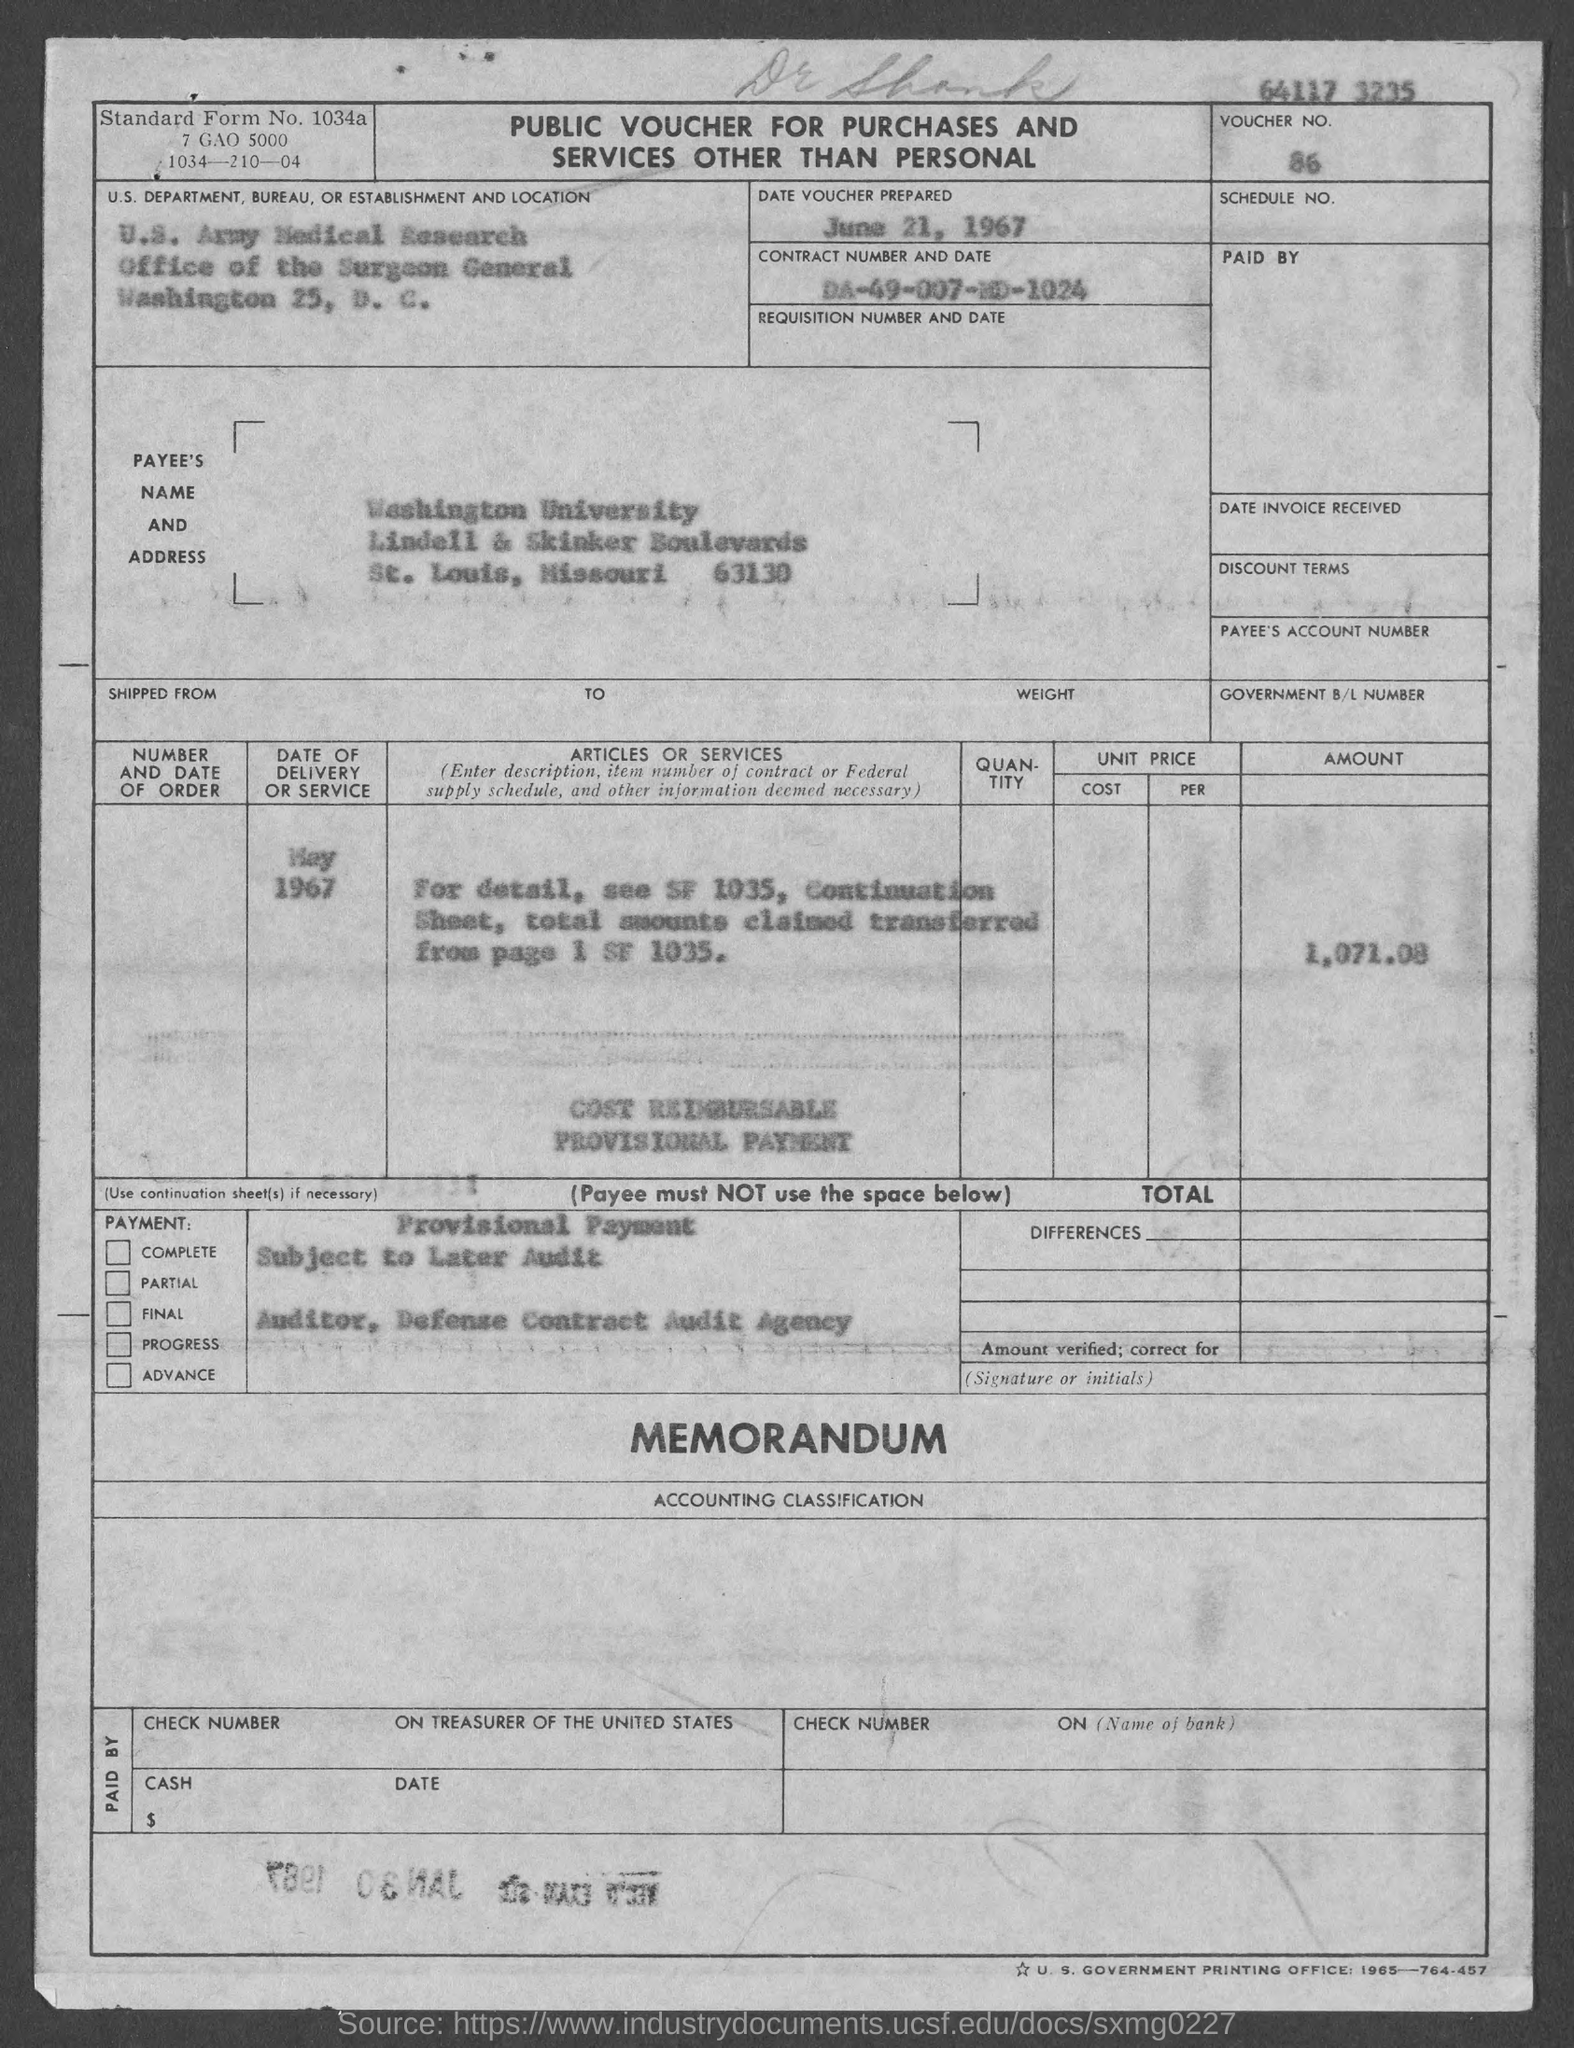Indicate a few pertinent items in this graphic. The voucher amount mentioned in the document is 1,071.08. The payee's name listed on the voucher is Washington University. The Contract Number mentioned in the document is DA-49-007-MD-1024. The voucher was prepared on June 21, 1967. The voucher number mentioned in the document is 86. 